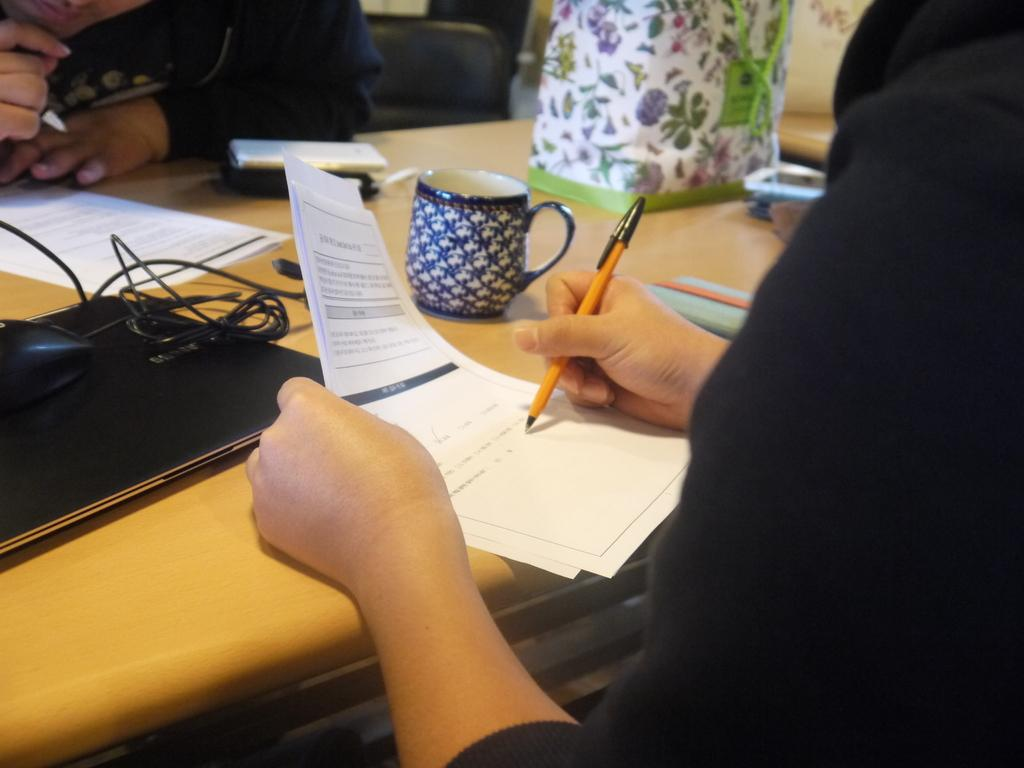What is the person in the image doing? The person is writing on a paper. What is the person using to write? The person is holding a pen. What objects are on the table in the image? There is a cup and a laptop on the table. What type of cord is connected to the laptop in the image? There is no cord connected to the laptop in the image. Is there a collar visible on the person in the image? There is no collar visible on the person in the image. 